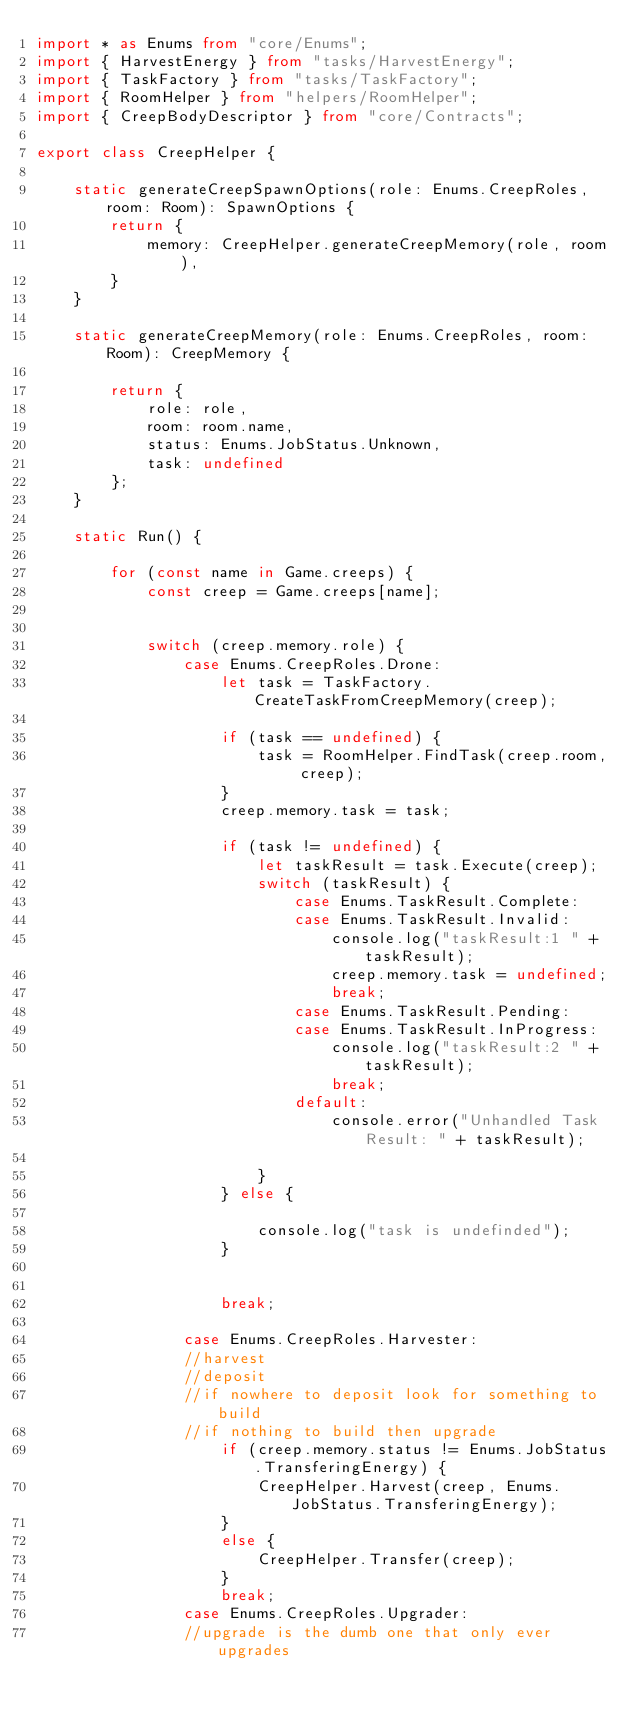Convert code to text. <code><loc_0><loc_0><loc_500><loc_500><_TypeScript_>import * as Enums from "core/Enums";
import { HarvestEnergy } from "tasks/HarvestEnergy";
import { TaskFactory } from "tasks/TaskFactory";
import { RoomHelper } from "helpers/RoomHelper";
import { CreepBodyDescriptor } from "core/Contracts";

export class CreepHelper {

    static generateCreepSpawnOptions(role: Enums.CreepRoles, room: Room): SpawnOptions {
        return {
            memory: CreepHelper.generateCreepMemory(role, room),
        }
    }

    static generateCreepMemory(role: Enums.CreepRoles, room: Room): CreepMemory {
    
        return {
            role: role,
            room: room.name,
            status: Enums.JobStatus.Unknown,
            task: undefined
        };
    }

    static Run() {

        for (const name in Game.creeps) {
            const creep = Game.creeps[name];
                        

            switch (creep.memory.role) {
                case Enums.CreepRoles.Drone:
                    let task = TaskFactory.CreateTaskFromCreepMemory(creep);

                    if (task == undefined) {
                        task = RoomHelper.FindTask(creep.room, creep);
                    }
                    creep.memory.task = task;

                    if (task != undefined) {
                        let taskResult = task.Execute(creep);
                        switch (taskResult) {
                            case Enums.TaskResult.Complete:
                            case Enums.TaskResult.Invalid:
                                console.log("taskResult:1 " + taskResult);
                                creep.memory.task = undefined;
                                break;
                            case Enums.TaskResult.Pending:
                            case Enums.TaskResult.InProgress:
                                console.log("taskResult:2 " + taskResult);
                                break;
                            default:
                                console.error("Unhandled Task Result: " + taskResult);

                        }
                    } else {

                        console.log("task is undefinded");
                    }

                
                    break;

                case Enums.CreepRoles.Harvester:
                //harvest
                //deposit
                //if nowhere to deposit look for something to build
                //if nothing to build then upgrade
                    if (creep.memory.status != Enums.JobStatus.TransferingEnergy) {
                        CreepHelper.Harvest(creep, Enums.JobStatus.TransferingEnergy);
                    }
                    else {
                        CreepHelper.Transfer(creep);
                    }
                    break;
                case Enums.CreepRoles.Upgrader:
                //upgrade is the dumb one that only ever upgrades</code> 